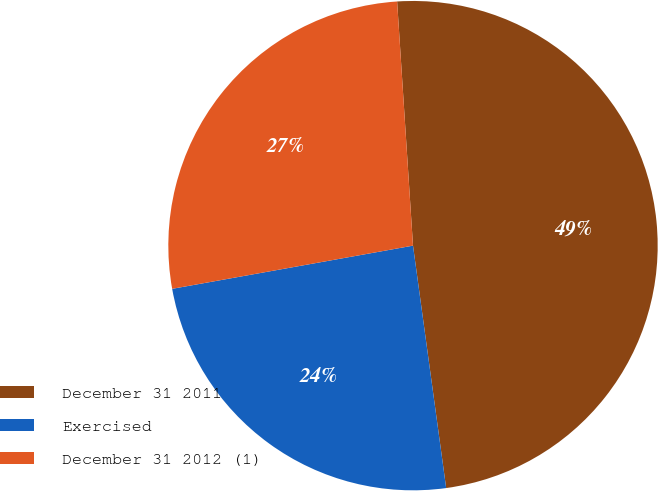<chart> <loc_0><loc_0><loc_500><loc_500><pie_chart><fcel>December 31 2011<fcel>Exercised<fcel>December 31 2012 (1)<nl><fcel>48.87%<fcel>24.34%<fcel>26.79%<nl></chart> 